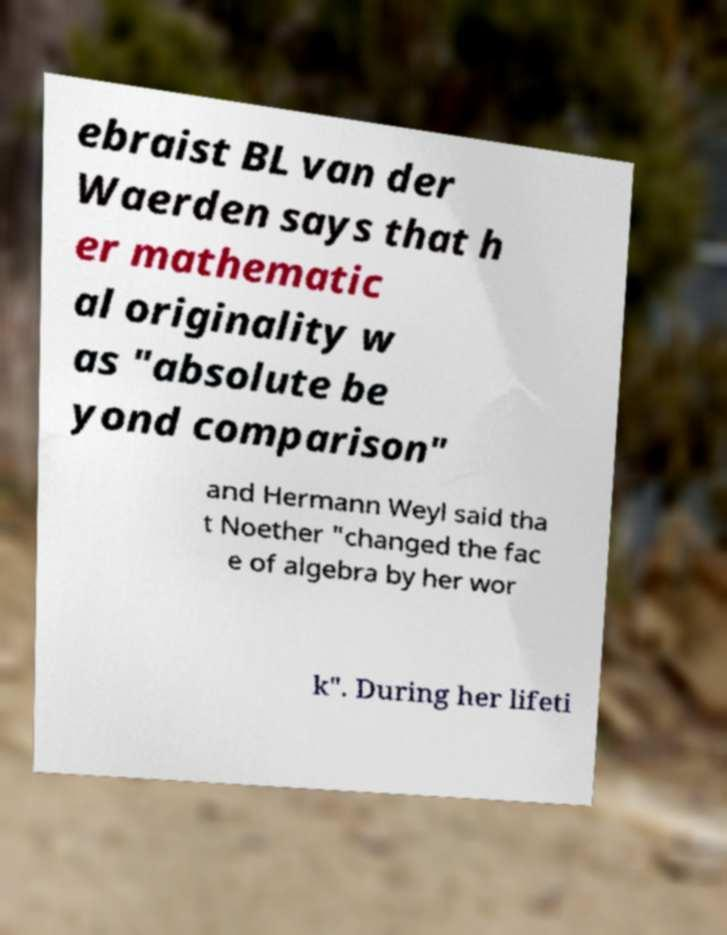What messages or text are displayed in this image? I need them in a readable, typed format. ebraist BL van der Waerden says that h er mathematic al originality w as "absolute be yond comparison" and Hermann Weyl said tha t Noether "changed the fac e of algebra by her wor k". During her lifeti 